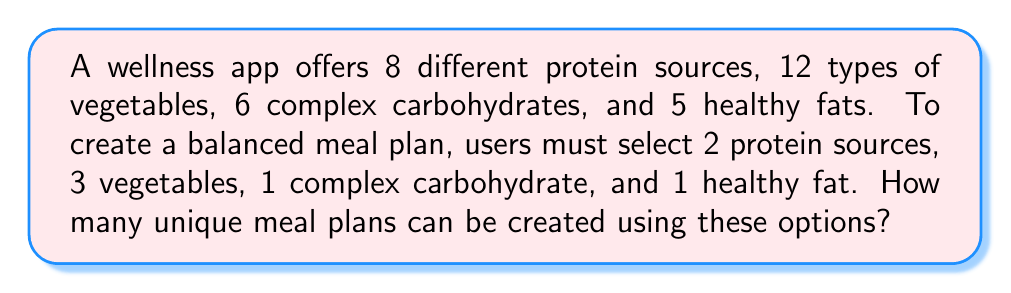Provide a solution to this math problem. To solve this problem, we need to use the multiplication principle of counting and combinations. Let's break it down step by step:

1. Selecting protein sources:
   We need to choose 2 protein sources out of 8 options. This is a combination problem.
   Number of ways to select proteins = $\binom{8}{2} = \frac{8!}{2!(8-2)!} = \frac{8 \cdot 7}{2 \cdot 1} = 28$

2. Selecting vegetables:
   We need to choose 3 vegetables out of 12 options.
   Number of ways to select vegetables = $\binom{12}{3} = \frac{12!}{3!(12-3)!} = \frac{12 \cdot 11 \cdot 10}{3 \cdot 2 \cdot 1} = 220$

3. Selecting complex carbohydrate:
   We need to choose 1 carbohydrate out of 6 options.
   Number of ways to select carbohydrate = $\binom{6}{1} = 6$

4. Selecting healthy fat:
   We need to choose 1 fat out of 5 options.
   Number of ways to select fat = $\binom{5}{1} = 5$

Now, we apply the multiplication principle. The total number of unique meal plans is the product of the number of ways to select each component:

$$ \text{Total meal plans} = 28 \cdot 220 \cdot 6 \cdot 5 $$

Calculating this:
$$ 28 \cdot 220 \cdot 6 \cdot 5 = 184,800 $$

Therefore, there are 184,800 unique meal plans that can be created using the given options.
Answer: 184,800 unique meal plans 